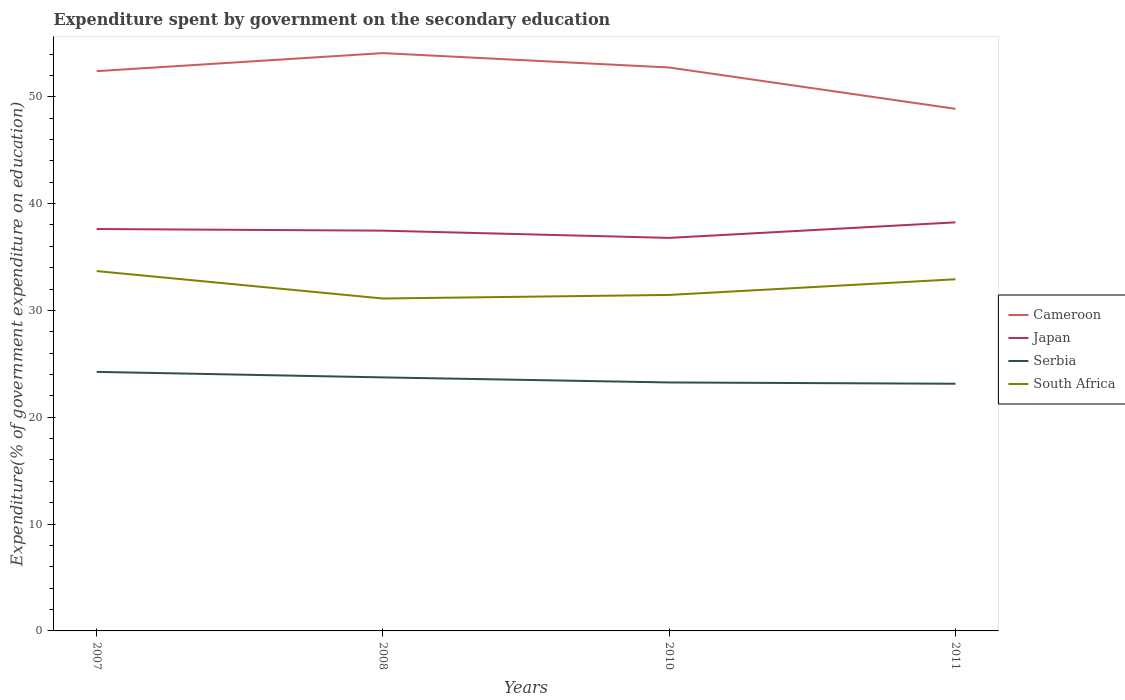Across all years, what is the maximum expenditure spent by government on the secondary education in South Africa?
Keep it short and to the point. 31.12. In which year was the expenditure spent by government on the secondary education in Cameroon maximum?
Provide a succinct answer. 2011. What is the total expenditure spent by government on the secondary education in Japan in the graph?
Provide a succinct answer. 0.15. What is the difference between the highest and the second highest expenditure spent by government on the secondary education in South Africa?
Give a very brief answer. 2.57. What is the difference between two consecutive major ticks on the Y-axis?
Provide a short and direct response. 10. Does the graph contain grids?
Provide a succinct answer. No. How many legend labels are there?
Offer a terse response. 4. How are the legend labels stacked?
Offer a very short reply. Vertical. What is the title of the graph?
Provide a short and direct response. Expenditure spent by government on the secondary education. Does "Vietnam" appear as one of the legend labels in the graph?
Make the answer very short. No. What is the label or title of the X-axis?
Offer a terse response. Years. What is the label or title of the Y-axis?
Make the answer very short. Expenditure(% of government expenditure on education). What is the Expenditure(% of government expenditure on education) of Cameroon in 2007?
Make the answer very short. 52.4. What is the Expenditure(% of government expenditure on education) in Japan in 2007?
Keep it short and to the point. 37.62. What is the Expenditure(% of government expenditure on education) of Serbia in 2007?
Make the answer very short. 24.25. What is the Expenditure(% of government expenditure on education) in South Africa in 2007?
Provide a short and direct response. 33.68. What is the Expenditure(% of government expenditure on education) of Cameroon in 2008?
Offer a terse response. 54.09. What is the Expenditure(% of government expenditure on education) of Japan in 2008?
Your response must be concise. 37.47. What is the Expenditure(% of government expenditure on education) of Serbia in 2008?
Ensure brevity in your answer.  23.73. What is the Expenditure(% of government expenditure on education) in South Africa in 2008?
Offer a terse response. 31.12. What is the Expenditure(% of government expenditure on education) in Cameroon in 2010?
Keep it short and to the point. 52.74. What is the Expenditure(% of government expenditure on education) in Japan in 2010?
Give a very brief answer. 36.79. What is the Expenditure(% of government expenditure on education) of Serbia in 2010?
Your answer should be compact. 23.26. What is the Expenditure(% of government expenditure on education) of South Africa in 2010?
Make the answer very short. 31.45. What is the Expenditure(% of government expenditure on education) of Cameroon in 2011?
Your response must be concise. 48.87. What is the Expenditure(% of government expenditure on education) of Japan in 2011?
Provide a succinct answer. 38.24. What is the Expenditure(% of government expenditure on education) of Serbia in 2011?
Your answer should be very brief. 23.14. What is the Expenditure(% of government expenditure on education) of South Africa in 2011?
Your response must be concise. 32.92. Across all years, what is the maximum Expenditure(% of government expenditure on education) in Cameroon?
Your answer should be compact. 54.09. Across all years, what is the maximum Expenditure(% of government expenditure on education) in Japan?
Make the answer very short. 38.24. Across all years, what is the maximum Expenditure(% of government expenditure on education) of Serbia?
Ensure brevity in your answer.  24.25. Across all years, what is the maximum Expenditure(% of government expenditure on education) in South Africa?
Your response must be concise. 33.68. Across all years, what is the minimum Expenditure(% of government expenditure on education) in Cameroon?
Provide a succinct answer. 48.87. Across all years, what is the minimum Expenditure(% of government expenditure on education) in Japan?
Provide a succinct answer. 36.79. Across all years, what is the minimum Expenditure(% of government expenditure on education) in Serbia?
Provide a succinct answer. 23.14. Across all years, what is the minimum Expenditure(% of government expenditure on education) of South Africa?
Your answer should be compact. 31.12. What is the total Expenditure(% of government expenditure on education) of Cameroon in the graph?
Keep it short and to the point. 208.09. What is the total Expenditure(% of government expenditure on education) of Japan in the graph?
Make the answer very short. 150.12. What is the total Expenditure(% of government expenditure on education) in Serbia in the graph?
Give a very brief answer. 94.38. What is the total Expenditure(% of government expenditure on education) of South Africa in the graph?
Your answer should be very brief. 129.17. What is the difference between the Expenditure(% of government expenditure on education) in Cameroon in 2007 and that in 2008?
Offer a very short reply. -1.69. What is the difference between the Expenditure(% of government expenditure on education) in Japan in 2007 and that in 2008?
Make the answer very short. 0.15. What is the difference between the Expenditure(% of government expenditure on education) of Serbia in 2007 and that in 2008?
Give a very brief answer. 0.52. What is the difference between the Expenditure(% of government expenditure on education) in South Africa in 2007 and that in 2008?
Ensure brevity in your answer.  2.57. What is the difference between the Expenditure(% of government expenditure on education) in Cameroon in 2007 and that in 2010?
Provide a short and direct response. -0.34. What is the difference between the Expenditure(% of government expenditure on education) of Japan in 2007 and that in 2010?
Your answer should be compact. 0.83. What is the difference between the Expenditure(% of government expenditure on education) in South Africa in 2007 and that in 2010?
Keep it short and to the point. 2.23. What is the difference between the Expenditure(% of government expenditure on education) in Cameroon in 2007 and that in 2011?
Provide a short and direct response. 3.53. What is the difference between the Expenditure(% of government expenditure on education) of Japan in 2007 and that in 2011?
Keep it short and to the point. -0.62. What is the difference between the Expenditure(% of government expenditure on education) of Serbia in 2007 and that in 2011?
Offer a terse response. 1.11. What is the difference between the Expenditure(% of government expenditure on education) in South Africa in 2007 and that in 2011?
Offer a very short reply. 0.77. What is the difference between the Expenditure(% of government expenditure on education) in Cameroon in 2008 and that in 2010?
Provide a succinct answer. 1.35. What is the difference between the Expenditure(% of government expenditure on education) of Japan in 2008 and that in 2010?
Your response must be concise. 0.68. What is the difference between the Expenditure(% of government expenditure on education) in Serbia in 2008 and that in 2010?
Offer a terse response. 0.47. What is the difference between the Expenditure(% of government expenditure on education) in South Africa in 2008 and that in 2010?
Your answer should be compact. -0.33. What is the difference between the Expenditure(% of government expenditure on education) of Cameroon in 2008 and that in 2011?
Make the answer very short. 5.22. What is the difference between the Expenditure(% of government expenditure on education) of Japan in 2008 and that in 2011?
Your answer should be compact. -0.78. What is the difference between the Expenditure(% of government expenditure on education) in Serbia in 2008 and that in 2011?
Your answer should be very brief. 0.59. What is the difference between the Expenditure(% of government expenditure on education) of South Africa in 2008 and that in 2011?
Ensure brevity in your answer.  -1.8. What is the difference between the Expenditure(% of government expenditure on education) in Cameroon in 2010 and that in 2011?
Offer a terse response. 3.87. What is the difference between the Expenditure(% of government expenditure on education) of Japan in 2010 and that in 2011?
Offer a very short reply. -1.45. What is the difference between the Expenditure(% of government expenditure on education) of Serbia in 2010 and that in 2011?
Your answer should be compact. 0.12. What is the difference between the Expenditure(% of government expenditure on education) in South Africa in 2010 and that in 2011?
Provide a short and direct response. -1.47. What is the difference between the Expenditure(% of government expenditure on education) of Cameroon in 2007 and the Expenditure(% of government expenditure on education) of Japan in 2008?
Offer a terse response. 14.93. What is the difference between the Expenditure(% of government expenditure on education) in Cameroon in 2007 and the Expenditure(% of government expenditure on education) in Serbia in 2008?
Ensure brevity in your answer.  28.66. What is the difference between the Expenditure(% of government expenditure on education) of Cameroon in 2007 and the Expenditure(% of government expenditure on education) of South Africa in 2008?
Provide a short and direct response. 21.28. What is the difference between the Expenditure(% of government expenditure on education) of Japan in 2007 and the Expenditure(% of government expenditure on education) of Serbia in 2008?
Your answer should be compact. 13.89. What is the difference between the Expenditure(% of government expenditure on education) of Japan in 2007 and the Expenditure(% of government expenditure on education) of South Africa in 2008?
Offer a very short reply. 6.5. What is the difference between the Expenditure(% of government expenditure on education) in Serbia in 2007 and the Expenditure(% of government expenditure on education) in South Africa in 2008?
Provide a short and direct response. -6.87. What is the difference between the Expenditure(% of government expenditure on education) of Cameroon in 2007 and the Expenditure(% of government expenditure on education) of Japan in 2010?
Offer a terse response. 15.61. What is the difference between the Expenditure(% of government expenditure on education) in Cameroon in 2007 and the Expenditure(% of government expenditure on education) in Serbia in 2010?
Keep it short and to the point. 29.14. What is the difference between the Expenditure(% of government expenditure on education) of Cameroon in 2007 and the Expenditure(% of government expenditure on education) of South Africa in 2010?
Provide a short and direct response. 20.95. What is the difference between the Expenditure(% of government expenditure on education) in Japan in 2007 and the Expenditure(% of government expenditure on education) in Serbia in 2010?
Keep it short and to the point. 14.36. What is the difference between the Expenditure(% of government expenditure on education) of Japan in 2007 and the Expenditure(% of government expenditure on education) of South Africa in 2010?
Offer a very short reply. 6.17. What is the difference between the Expenditure(% of government expenditure on education) in Serbia in 2007 and the Expenditure(% of government expenditure on education) in South Africa in 2010?
Your answer should be very brief. -7.2. What is the difference between the Expenditure(% of government expenditure on education) in Cameroon in 2007 and the Expenditure(% of government expenditure on education) in Japan in 2011?
Your response must be concise. 14.15. What is the difference between the Expenditure(% of government expenditure on education) of Cameroon in 2007 and the Expenditure(% of government expenditure on education) of Serbia in 2011?
Your answer should be very brief. 29.26. What is the difference between the Expenditure(% of government expenditure on education) of Cameroon in 2007 and the Expenditure(% of government expenditure on education) of South Africa in 2011?
Give a very brief answer. 19.48. What is the difference between the Expenditure(% of government expenditure on education) of Japan in 2007 and the Expenditure(% of government expenditure on education) of Serbia in 2011?
Offer a very short reply. 14.48. What is the difference between the Expenditure(% of government expenditure on education) in Japan in 2007 and the Expenditure(% of government expenditure on education) in South Africa in 2011?
Offer a terse response. 4.7. What is the difference between the Expenditure(% of government expenditure on education) in Serbia in 2007 and the Expenditure(% of government expenditure on education) in South Africa in 2011?
Keep it short and to the point. -8.67. What is the difference between the Expenditure(% of government expenditure on education) in Cameroon in 2008 and the Expenditure(% of government expenditure on education) in Japan in 2010?
Your answer should be compact. 17.3. What is the difference between the Expenditure(% of government expenditure on education) in Cameroon in 2008 and the Expenditure(% of government expenditure on education) in Serbia in 2010?
Give a very brief answer. 30.83. What is the difference between the Expenditure(% of government expenditure on education) of Cameroon in 2008 and the Expenditure(% of government expenditure on education) of South Africa in 2010?
Make the answer very short. 22.64. What is the difference between the Expenditure(% of government expenditure on education) of Japan in 2008 and the Expenditure(% of government expenditure on education) of Serbia in 2010?
Your answer should be very brief. 14.21. What is the difference between the Expenditure(% of government expenditure on education) in Japan in 2008 and the Expenditure(% of government expenditure on education) in South Africa in 2010?
Keep it short and to the point. 6.02. What is the difference between the Expenditure(% of government expenditure on education) of Serbia in 2008 and the Expenditure(% of government expenditure on education) of South Africa in 2010?
Your answer should be compact. -7.72. What is the difference between the Expenditure(% of government expenditure on education) of Cameroon in 2008 and the Expenditure(% of government expenditure on education) of Japan in 2011?
Make the answer very short. 15.84. What is the difference between the Expenditure(% of government expenditure on education) of Cameroon in 2008 and the Expenditure(% of government expenditure on education) of Serbia in 2011?
Your answer should be compact. 30.95. What is the difference between the Expenditure(% of government expenditure on education) in Cameroon in 2008 and the Expenditure(% of government expenditure on education) in South Africa in 2011?
Provide a succinct answer. 21.17. What is the difference between the Expenditure(% of government expenditure on education) in Japan in 2008 and the Expenditure(% of government expenditure on education) in Serbia in 2011?
Provide a succinct answer. 14.33. What is the difference between the Expenditure(% of government expenditure on education) in Japan in 2008 and the Expenditure(% of government expenditure on education) in South Africa in 2011?
Offer a very short reply. 4.55. What is the difference between the Expenditure(% of government expenditure on education) of Serbia in 2008 and the Expenditure(% of government expenditure on education) of South Africa in 2011?
Ensure brevity in your answer.  -9.18. What is the difference between the Expenditure(% of government expenditure on education) of Cameroon in 2010 and the Expenditure(% of government expenditure on education) of Japan in 2011?
Your answer should be compact. 14.5. What is the difference between the Expenditure(% of government expenditure on education) of Cameroon in 2010 and the Expenditure(% of government expenditure on education) of Serbia in 2011?
Keep it short and to the point. 29.6. What is the difference between the Expenditure(% of government expenditure on education) in Cameroon in 2010 and the Expenditure(% of government expenditure on education) in South Africa in 2011?
Offer a very short reply. 19.82. What is the difference between the Expenditure(% of government expenditure on education) in Japan in 2010 and the Expenditure(% of government expenditure on education) in Serbia in 2011?
Give a very brief answer. 13.65. What is the difference between the Expenditure(% of government expenditure on education) in Japan in 2010 and the Expenditure(% of government expenditure on education) in South Africa in 2011?
Make the answer very short. 3.87. What is the difference between the Expenditure(% of government expenditure on education) in Serbia in 2010 and the Expenditure(% of government expenditure on education) in South Africa in 2011?
Give a very brief answer. -9.66. What is the average Expenditure(% of government expenditure on education) in Cameroon per year?
Give a very brief answer. 52.02. What is the average Expenditure(% of government expenditure on education) of Japan per year?
Your response must be concise. 37.53. What is the average Expenditure(% of government expenditure on education) of Serbia per year?
Provide a short and direct response. 23.59. What is the average Expenditure(% of government expenditure on education) in South Africa per year?
Provide a succinct answer. 32.29. In the year 2007, what is the difference between the Expenditure(% of government expenditure on education) in Cameroon and Expenditure(% of government expenditure on education) in Japan?
Provide a succinct answer. 14.78. In the year 2007, what is the difference between the Expenditure(% of government expenditure on education) of Cameroon and Expenditure(% of government expenditure on education) of Serbia?
Provide a short and direct response. 28.15. In the year 2007, what is the difference between the Expenditure(% of government expenditure on education) in Cameroon and Expenditure(% of government expenditure on education) in South Africa?
Give a very brief answer. 18.71. In the year 2007, what is the difference between the Expenditure(% of government expenditure on education) of Japan and Expenditure(% of government expenditure on education) of Serbia?
Your response must be concise. 13.37. In the year 2007, what is the difference between the Expenditure(% of government expenditure on education) of Japan and Expenditure(% of government expenditure on education) of South Africa?
Offer a very short reply. 3.94. In the year 2007, what is the difference between the Expenditure(% of government expenditure on education) in Serbia and Expenditure(% of government expenditure on education) in South Africa?
Make the answer very short. -9.44. In the year 2008, what is the difference between the Expenditure(% of government expenditure on education) in Cameroon and Expenditure(% of government expenditure on education) in Japan?
Provide a short and direct response. 16.62. In the year 2008, what is the difference between the Expenditure(% of government expenditure on education) of Cameroon and Expenditure(% of government expenditure on education) of Serbia?
Provide a succinct answer. 30.35. In the year 2008, what is the difference between the Expenditure(% of government expenditure on education) in Cameroon and Expenditure(% of government expenditure on education) in South Africa?
Your response must be concise. 22.97. In the year 2008, what is the difference between the Expenditure(% of government expenditure on education) of Japan and Expenditure(% of government expenditure on education) of Serbia?
Give a very brief answer. 13.73. In the year 2008, what is the difference between the Expenditure(% of government expenditure on education) in Japan and Expenditure(% of government expenditure on education) in South Africa?
Ensure brevity in your answer.  6.35. In the year 2008, what is the difference between the Expenditure(% of government expenditure on education) in Serbia and Expenditure(% of government expenditure on education) in South Africa?
Provide a short and direct response. -7.38. In the year 2010, what is the difference between the Expenditure(% of government expenditure on education) of Cameroon and Expenditure(% of government expenditure on education) of Japan?
Keep it short and to the point. 15.95. In the year 2010, what is the difference between the Expenditure(% of government expenditure on education) in Cameroon and Expenditure(% of government expenditure on education) in Serbia?
Keep it short and to the point. 29.48. In the year 2010, what is the difference between the Expenditure(% of government expenditure on education) of Cameroon and Expenditure(% of government expenditure on education) of South Africa?
Ensure brevity in your answer.  21.29. In the year 2010, what is the difference between the Expenditure(% of government expenditure on education) of Japan and Expenditure(% of government expenditure on education) of Serbia?
Ensure brevity in your answer.  13.53. In the year 2010, what is the difference between the Expenditure(% of government expenditure on education) in Japan and Expenditure(% of government expenditure on education) in South Africa?
Ensure brevity in your answer.  5.34. In the year 2010, what is the difference between the Expenditure(% of government expenditure on education) of Serbia and Expenditure(% of government expenditure on education) of South Africa?
Your answer should be compact. -8.19. In the year 2011, what is the difference between the Expenditure(% of government expenditure on education) in Cameroon and Expenditure(% of government expenditure on education) in Japan?
Your response must be concise. 10.63. In the year 2011, what is the difference between the Expenditure(% of government expenditure on education) of Cameroon and Expenditure(% of government expenditure on education) of Serbia?
Your answer should be very brief. 25.73. In the year 2011, what is the difference between the Expenditure(% of government expenditure on education) in Cameroon and Expenditure(% of government expenditure on education) in South Africa?
Provide a short and direct response. 15.95. In the year 2011, what is the difference between the Expenditure(% of government expenditure on education) of Japan and Expenditure(% of government expenditure on education) of Serbia?
Your response must be concise. 15.11. In the year 2011, what is the difference between the Expenditure(% of government expenditure on education) in Japan and Expenditure(% of government expenditure on education) in South Africa?
Keep it short and to the point. 5.33. In the year 2011, what is the difference between the Expenditure(% of government expenditure on education) in Serbia and Expenditure(% of government expenditure on education) in South Africa?
Provide a succinct answer. -9.78. What is the ratio of the Expenditure(% of government expenditure on education) in Cameroon in 2007 to that in 2008?
Give a very brief answer. 0.97. What is the ratio of the Expenditure(% of government expenditure on education) of Serbia in 2007 to that in 2008?
Your response must be concise. 1.02. What is the ratio of the Expenditure(% of government expenditure on education) of South Africa in 2007 to that in 2008?
Provide a succinct answer. 1.08. What is the ratio of the Expenditure(% of government expenditure on education) of Japan in 2007 to that in 2010?
Your answer should be compact. 1.02. What is the ratio of the Expenditure(% of government expenditure on education) of Serbia in 2007 to that in 2010?
Offer a very short reply. 1.04. What is the ratio of the Expenditure(% of government expenditure on education) in South Africa in 2007 to that in 2010?
Offer a very short reply. 1.07. What is the ratio of the Expenditure(% of government expenditure on education) of Cameroon in 2007 to that in 2011?
Keep it short and to the point. 1.07. What is the ratio of the Expenditure(% of government expenditure on education) of Japan in 2007 to that in 2011?
Your answer should be compact. 0.98. What is the ratio of the Expenditure(% of government expenditure on education) in Serbia in 2007 to that in 2011?
Your answer should be compact. 1.05. What is the ratio of the Expenditure(% of government expenditure on education) in South Africa in 2007 to that in 2011?
Make the answer very short. 1.02. What is the ratio of the Expenditure(% of government expenditure on education) of Cameroon in 2008 to that in 2010?
Ensure brevity in your answer.  1.03. What is the ratio of the Expenditure(% of government expenditure on education) of Japan in 2008 to that in 2010?
Your response must be concise. 1.02. What is the ratio of the Expenditure(% of government expenditure on education) in Serbia in 2008 to that in 2010?
Provide a succinct answer. 1.02. What is the ratio of the Expenditure(% of government expenditure on education) of South Africa in 2008 to that in 2010?
Make the answer very short. 0.99. What is the ratio of the Expenditure(% of government expenditure on education) in Cameroon in 2008 to that in 2011?
Make the answer very short. 1.11. What is the ratio of the Expenditure(% of government expenditure on education) in Japan in 2008 to that in 2011?
Provide a short and direct response. 0.98. What is the ratio of the Expenditure(% of government expenditure on education) of Serbia in 2008 to that in 2011?
Offer a very short reply. 1.03. What is the ratio of the Expenditure(% of government expenditure on education) of South Africa in 2008 to that in 2011?
Provide a short and direct response. 0.95. What is the ratio of the Expenditure(% of government expenditure on education) of Cameroon in 2010 to that in 2011?
Make the answer very short. 1.08. What is the ratio of the Expenditure(% of government expenditure on education) of Serbia in 2010 to that in 2011?
Give a very brief answer. 1.01. What is the ratio of the Expenditure(% of government expenditure on education) of South Africa in 2010 to that in 2011?
Provide a succinct answer. 0.96. What is the difference between the highest and the second highest Expenditure(% of government expenditure on education) in Cameroon?
Keep it short and to the point. 1.35. What is the difference between the highest and the second highest Expenditure(% of government expenditure on education) in Japan?
Keep it short and to the point. 0.62. What is the difference between the highest and the second highest Expenditure(% of government expenditure on education) in Serbia?
Your answer should be very brief. 0.52. What is the difference between the highest and the second highest Expenditure(% of government expenditure on education) in South Africa?
Offer a very short reply. 0.77. What is the difference between the highest and the lowest Expenditure(% of government expenditure on education) in Cameroon?
Your answer should be compact. 5.22. What is the difference between the highest and the lowest Expenditure(% of government expenditure on education) of Japan?
Offer a very short reply. 1.45. What is the difference between the highest and the lowest Expenditure(% of government expenditure on education) of Serbia?
Offer a terse response. 1.11. What is the difference between the highest and the lowest Expenditure(% of government expenditure on education) of South Africa?
Provide a short and direct response. 2.57. 